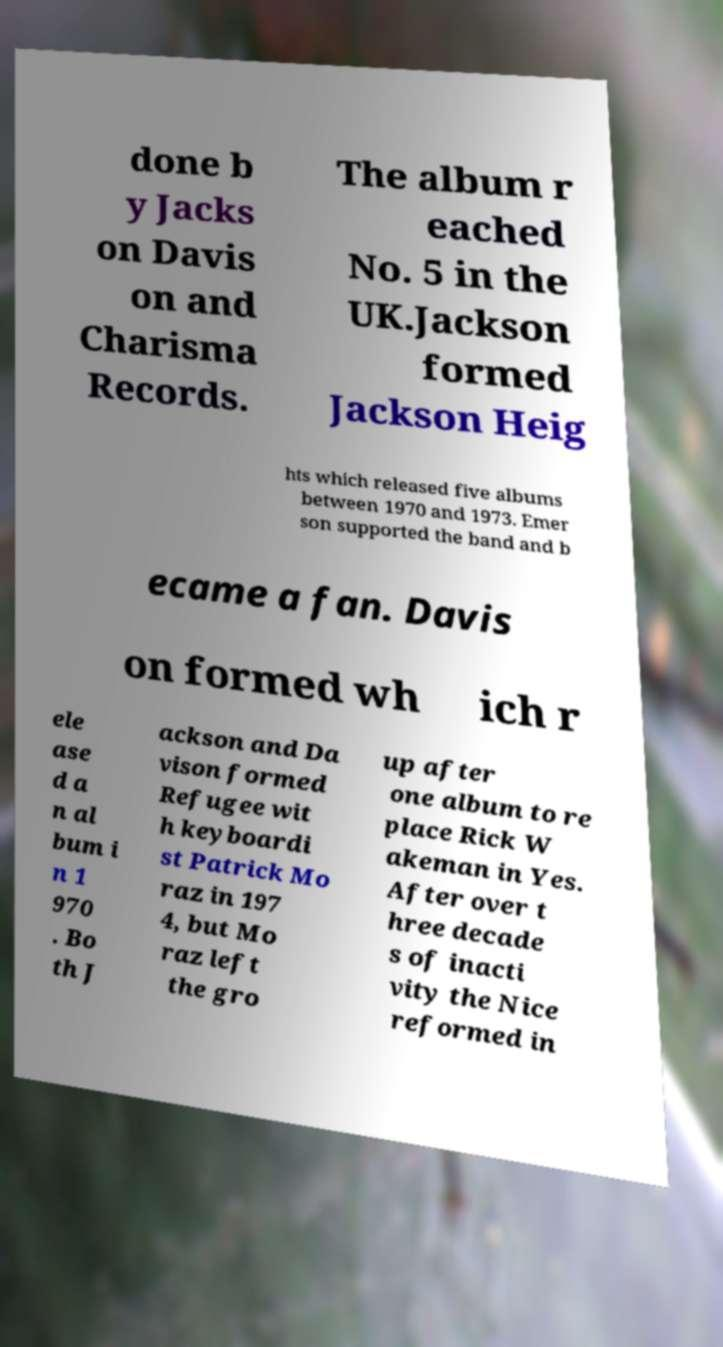I need the written content from this picture converted into text. Can you do that? done b y Jacks on Davis on and Charisma Records. The album r eached No. 5 in the UK.Jackson formed Jackson Heig hts which released five albums between 1970 and 1973. Emer son supported the band and b ecame a fan. Davis on formed wh ich r ele ase d a n al bum i n 1 970 . Bo th J ackson and Da vison formed Refugee wit h keyboardi st Patrick Mo raz in 197 4, but Mo raz left the gro up after one album to re place Rick W akeman in Yes. After over t hree decade s of inacti vity the Nice reformed in 